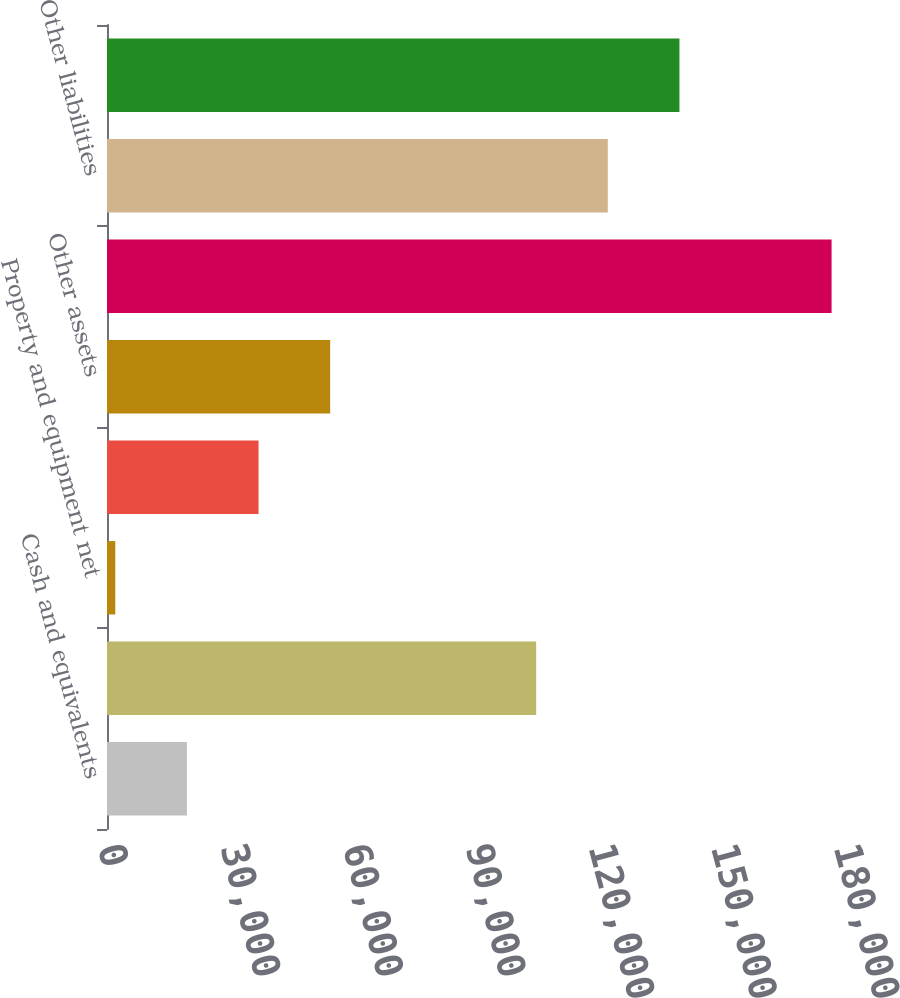Convert chart. <chart><loc_0><loc_0><loc_500><loc_500><bar_chart><fcel>Cash and equivalents<fcel>Trading securities<fcel>Property and equipment net<fcel>Other intangibles net<fcel>Other assets<fcel>Total assets<fcel>Other liabilities<fcel>Total liabilities<nl><fcel>19544.1<fcel>104963<fcel>2026<fcel>37062.2<fcel>54580.3<fcel>177207<fcel>122481<fcel>139999<nl></chart> 